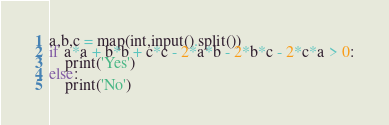Convert code to text. <code><loc_0><loc_0><loc_500><loc_500><_Python_>a,b,c = map(int,input().split())
if a*a + b*b + c*c - 2*a*b - 2*b*c - 2*c*a > 0:
    print('Yes')
else:
    print('No')</code> 